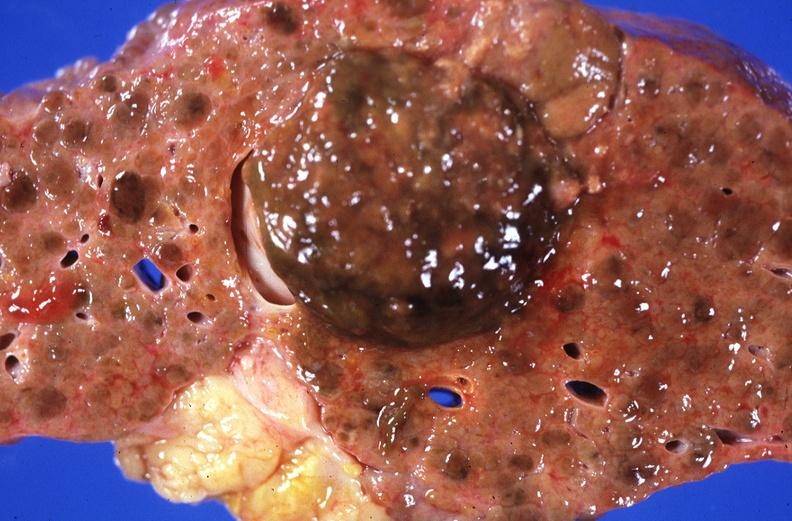does this image show hepatitis b virus, hepatocellular carcinoma?
Answer the question using a single word or phrase. Yes 